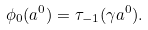<formula> <loc_0><loc_0><loc_500><loc_500>\phi _ { 0 } ( a ^ { 0 } ) = \tau _ { - 1 } ( \gamma a ^ { 0 } ) .</formula> 